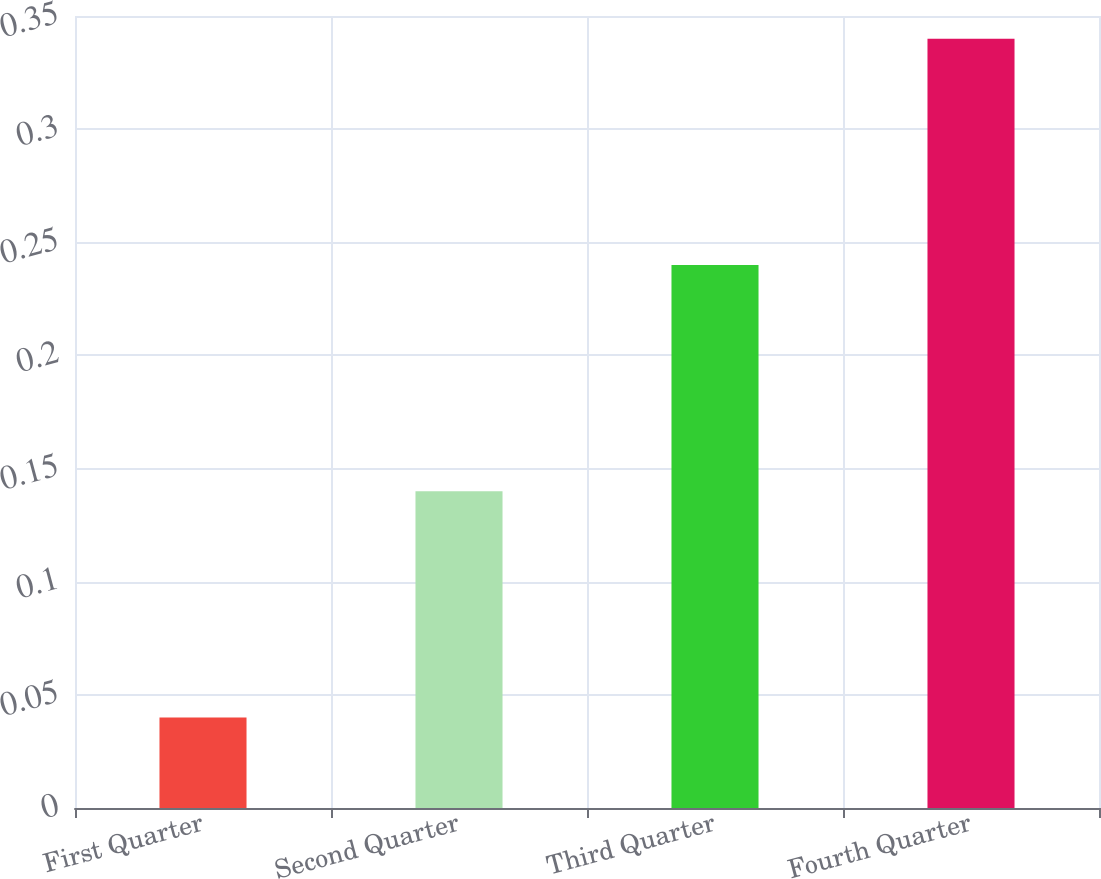Convert chart to OTSL. <chart><loc_0><loc_0><loc_500><loc_500><bar_chart><fcel>First Quarter<fcel>Second Quarter<fcel>Third Quarter<fcel>Fourth Quarter<nl><fcel>0.04<fcel>0.14<fcel>0.24<fcel>0.34<nl></chart> 